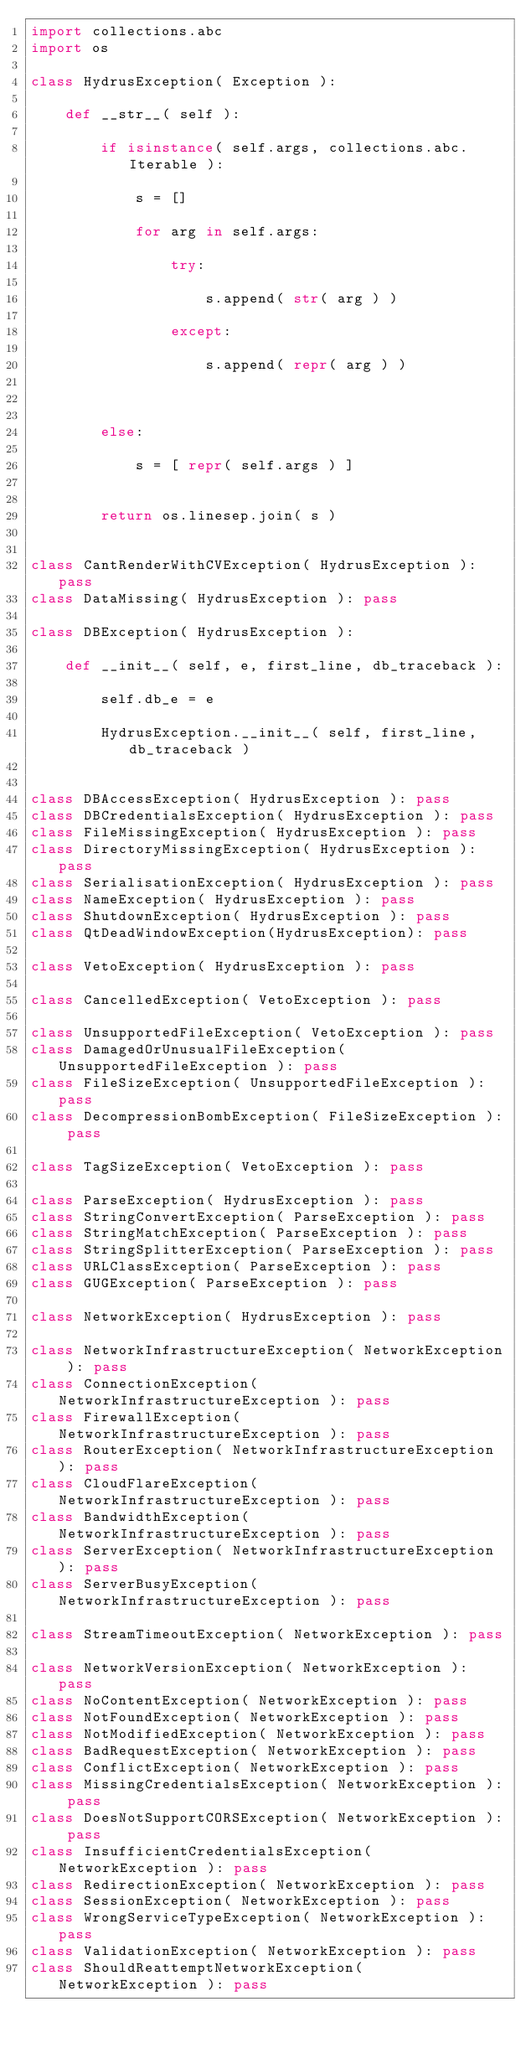Convert code to text. <code><loc_0><loc_0><loc_500><loc_500><_Python_>import collections.abc
import os

class HydrusException( Exception ):
    
    def __str__( self ):
        
        if isinstance( self.args, collections.abc.Iterable ):
            
            s = []
            
            for arg in self.args:
                
                try:
                    
                    s.append( str( arg ) )
                    
                except:
                    
                    s.append( repr( arg ) )
                    
                
            
        else:
            
            s = [ repr( self.args ) ]
            
        
        return os.linesep.join( s )
        
    
class CantRenderWithCVException( HydrusException ): pass
class DataMissing( HydrusException ): pass

class DBException( HydrusException ):
    
    def __init__( self, e, first_line, db_traceback ):
        
        self.db_e = e
        
        HydrusException.__init__( self, first_line, db_traceback )
        
    
class DBAccessException( HydrusException ): pass
class DBCredentialsException( HydrusException ): pass
class FileMissingException( HydrusException ): pass
class DirectoryMissingException( HydrusException ): pass
class SerialisationException( HydrusException ): pass
class NameException( HydrusException ): pass
class ShutdownException( HydrusException ): pass
class QtDeadWindowException(HydrusException): pass

class VetoException( HydrusException ): pass

class CancelledException( VetoException ): pass

class UnsupportedFileException( VetoException ): pass
class DamagedOrUnusualFileException( UnsupportedFileException ): pass
class FileSizeException( UnsupportedFileException ): pass
class DecompressionBombException( FileSizeException ): pass

class TagSizeException( VetoException ): pass

class ParseException( HydrusException ): pass
class StringConvertException( ParseException ): pass
class StringMatchException( ParseException ): pass
class StringSplitterException( ParseException ): pass
class URLClassException( ParseException ): pass
class GUGException( ParseException ): pass

class NetworkException( HydrusException ): pass

class NetworkInfrastructureException( NetworkException ): pass
class ConnectionException( NetworkInfrastructureException ): pass
class FirewallException( NetworkInfrastructureException ): pass
class RouterException( NetworkInfrastructureException ): pass
class CloudFlareException( NetworkInfrastructureException ): pass
class BandwidthException( NetworkInfrastructureException ): pass
class ServerException( NetworkInfrastructureException ): pass
class ServerBusyException( NetworkInfrastructureException ): pass

class StreamTimeoutException( NetworkException ): pass

class NetworkVersionException( NetworkException ): pass
class NoContentException( NetworkException ): pass
class NotFoundException( NetworkException ): pass
class NotModifiedException( NetworkException ): pass
class BadRequestException( NetworkException ): pass
class ConflictException( NetworkException ): pass
class MissingCredentialsException( NetworkException ): pass
class DoesNotSupportCORSException( NetworkException ): pass
class InsufficientCredentialsException( NetworkException ): pass
class RedirectionException( NetworkException ): pass
class SessionException( NetworkException ): pass
class WrongServiceTypeException( NetworkException ): pass
class ValidationException( NetworkException ): pass
class ShouldReattemptNetworkException( NetworkException ): pass
</code> 